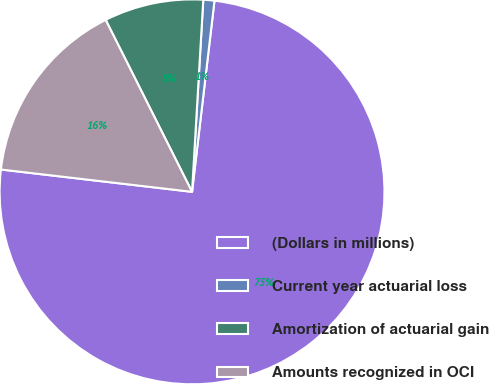<chart> <loc_0><loc_0><loc_500><loc_500><pie_chart><fcel>(Dollars in millions)<fcel>Current year actuarial loss<fcel>Amortization of actuarial gain<fcel>Amounts recognized in OCI<nl><fcel>74.99%<fcel>0.93%<fcel>8.34%<fcel>15.74%<nl></chart> 